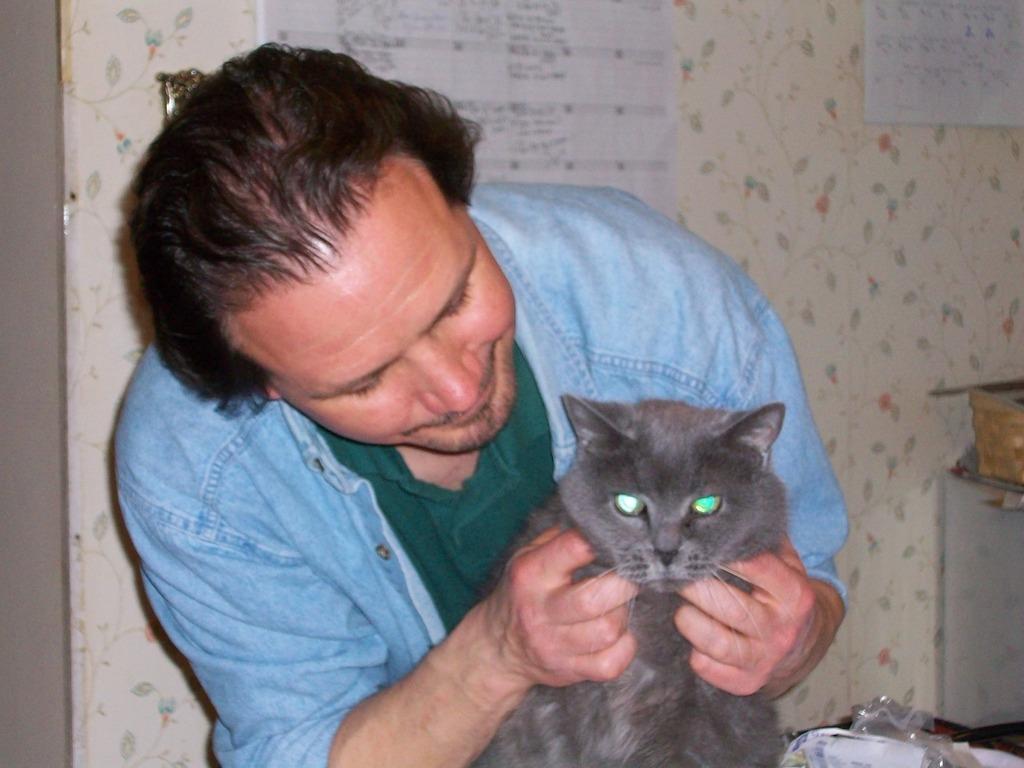Could you give a brief overview of what you see in this image? As we can see in the image, there is a man holding a cat. 